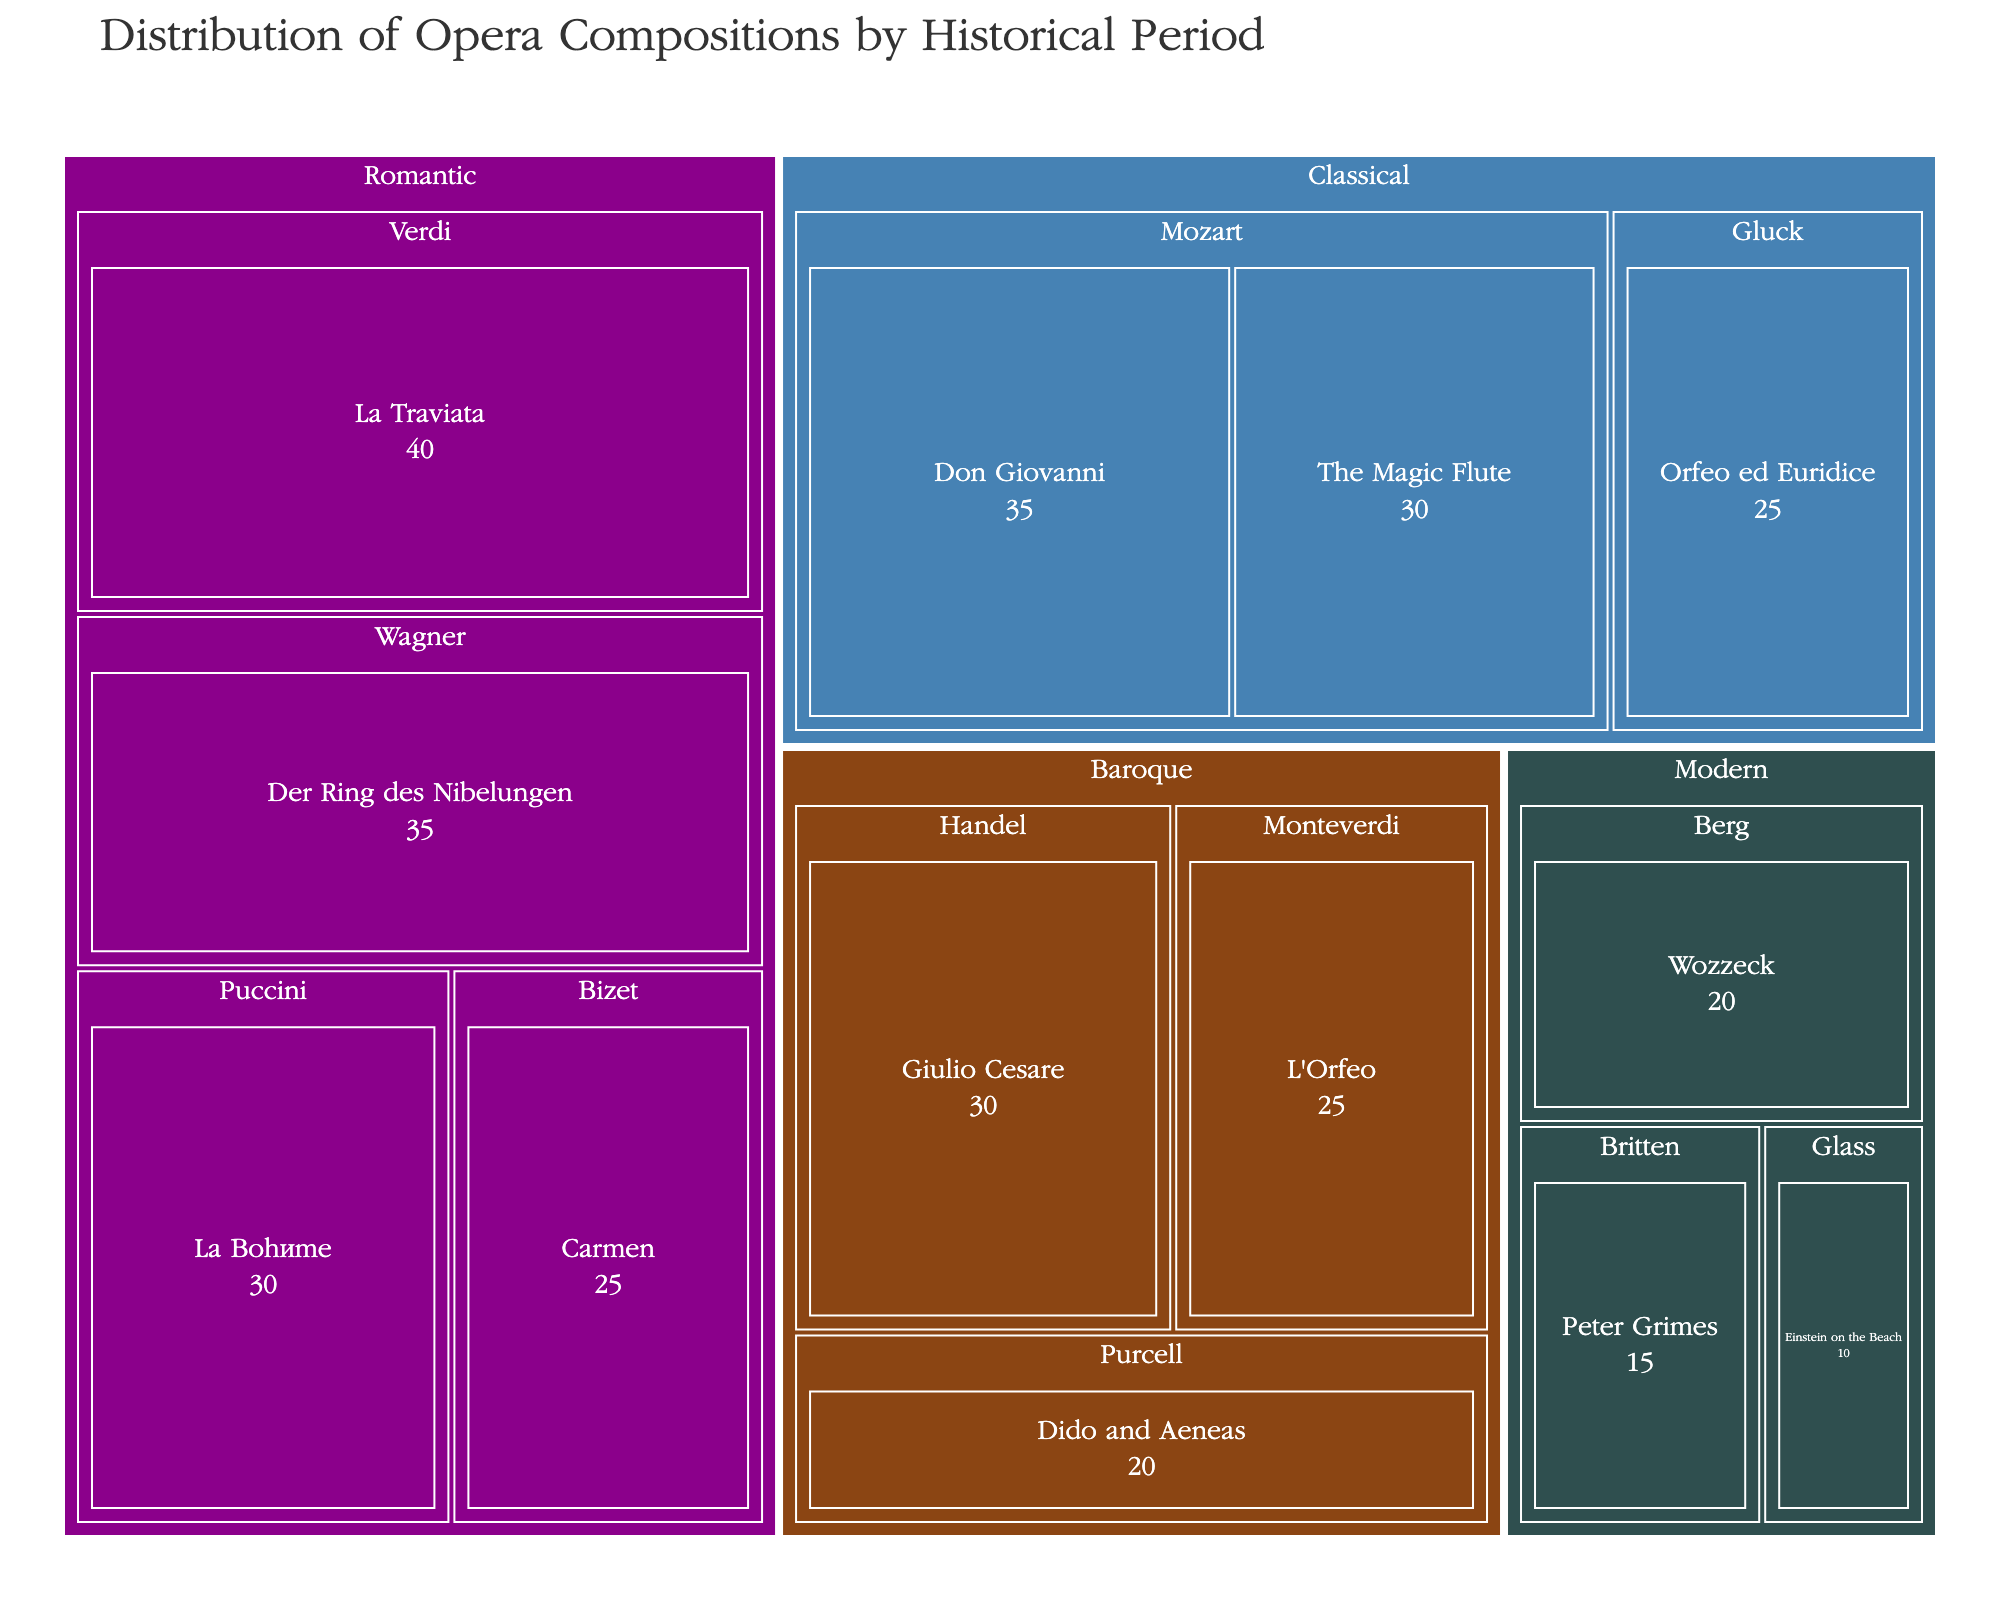What's the title of the figure? The title is usually placed at the top of the figure. In this case, we look at the top center part of the treemap.
Answer: Distribution of Opera Compositions by Historical Period Which historical period has the highest total value of compositions? Look at the different color-coded sections, and identify the one with the largest area. The area represents the total value of compositions.
Answer: Romantic How many compositions are represented in the Modern era? Identify the blocks within the Modern era section. Count the number of distinct compositions.
Answer: 3 What's the combined value of compositions by Mozart? Identify Mozart under the Classical section. Add the values of "Don Giovanni" and "The Magic Flute" together.
Answer: 65 Which composer has the highest individual composition value? Scan the figure to find the block with the largest value. Note the composer associated with that block.
Answer: Verdi Compare the total value of compositions in the Baroque and Classical periods, which is larger? Calculate the total value for each period by summing the values of individual compositions within each period. Compare the sums.
Answer: Classical What's the average value of compositions in the Romantic period? Add the values of all compositions in the Romantic period and divide by the number of compositions. (40 + 35 + 30 + 25) / 4
Answer: 32.5 What are the values of the top three compositions by value? Identify the three compositions with the largest individual values from any period.
Answer: La Traviata (40), Der Ring des Nibelungen (35), Don Giovanni (35) How many composers are represented in the Baroque period? Identify the blocks within the Baroque section and count the number of different composers listed.
Answer: 3 Compare the value of "Orfeo ed Euridice" with "Giulio Cesare". Which one is larger and by how much? Identify the individual values of "Orfeo ed Euridice" (25) and "Giulio Cesare" (30). Subtract the smaller value from the larger value.
Answer: Giulio Cesare by 5 